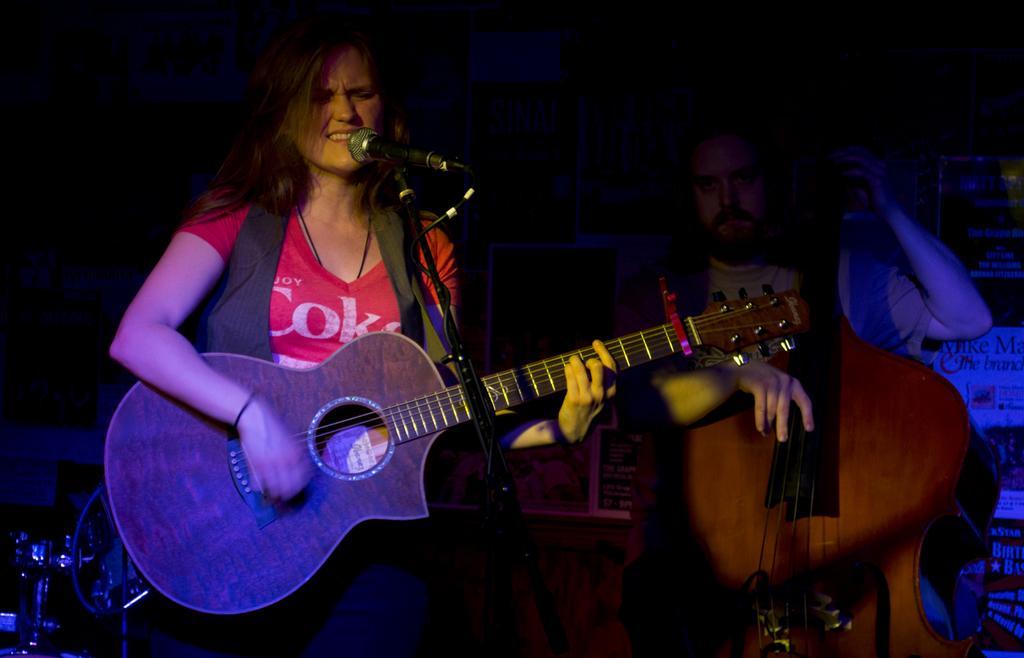In one or two sentences, can you explain what this image depicts? This picture shows a woman singing and playing a guitar in her hands. There and a stand in front of her. In the background there is another guy holding a large guitar. 